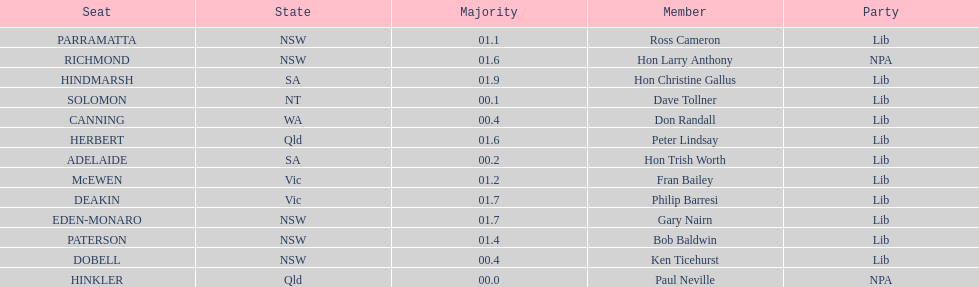Who is listed before don randall? Hon Trish Worth. 